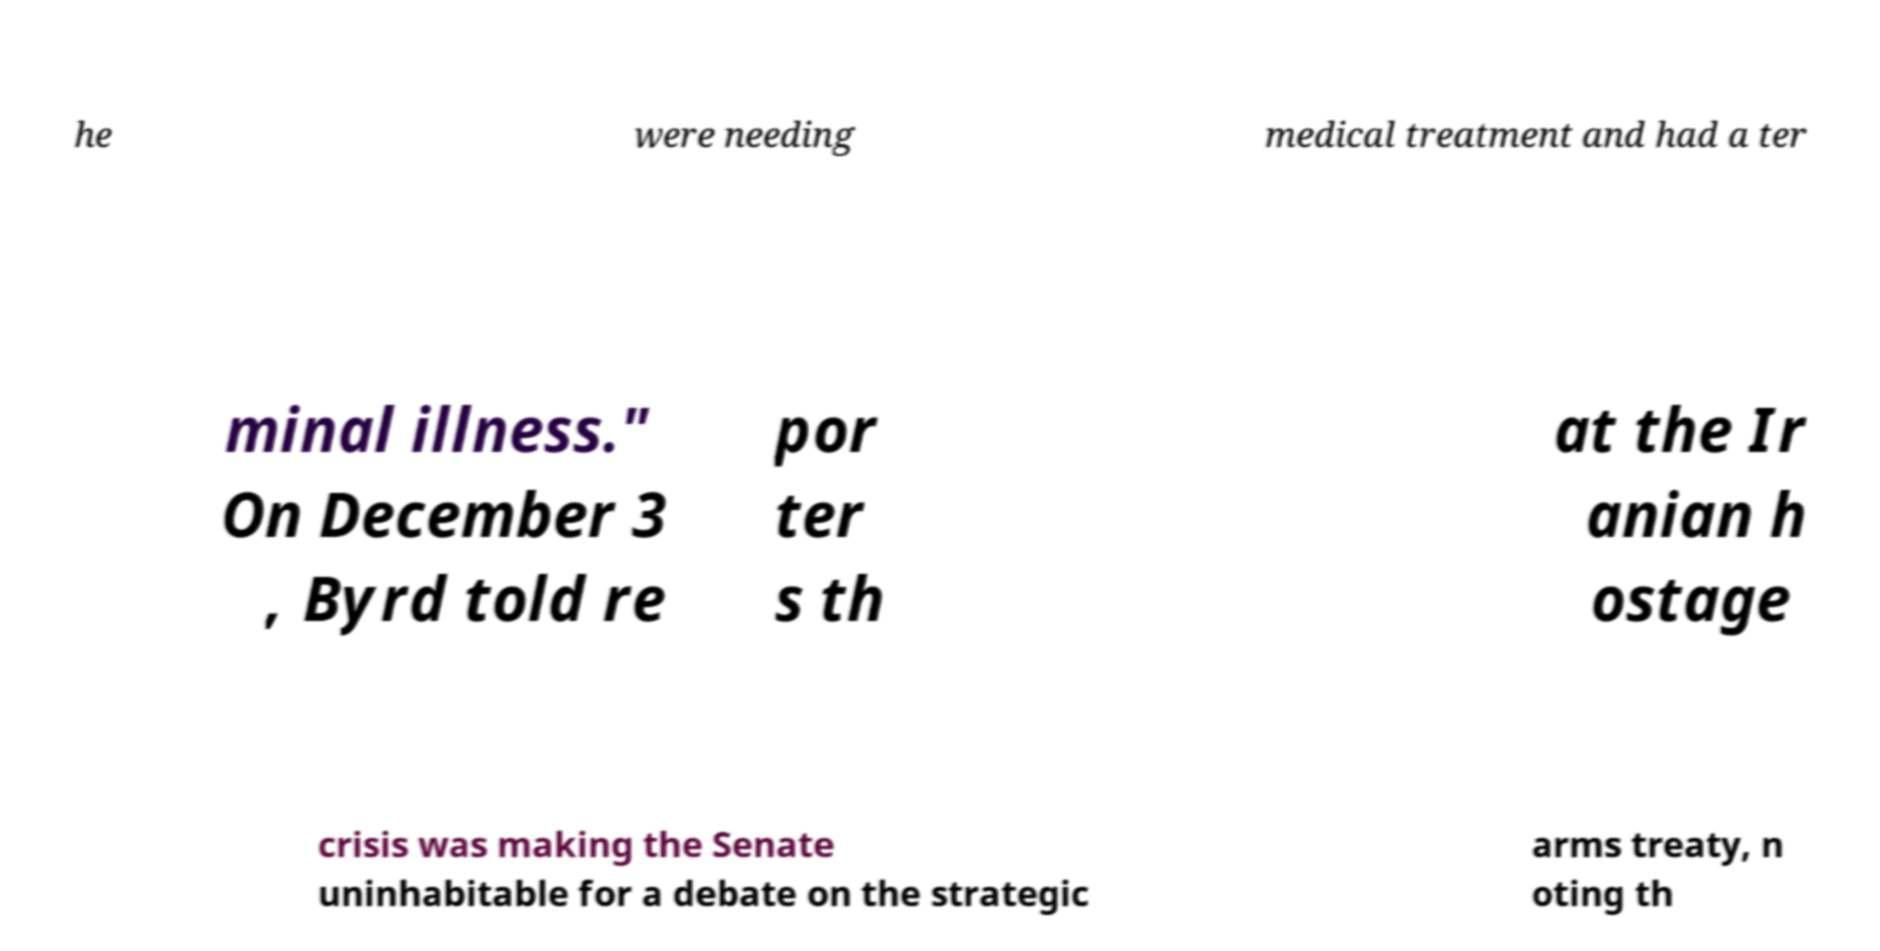Could you assist in decoding the text presented in this image and type it out clearly? he were needing medical treatment and had a ter minal illness." On December 3 , Byrd told re por ter s th at the Ir anian h ostage crisis was making the Senate uninhabitable for a debate on the strategic arms treaty, n oting th 